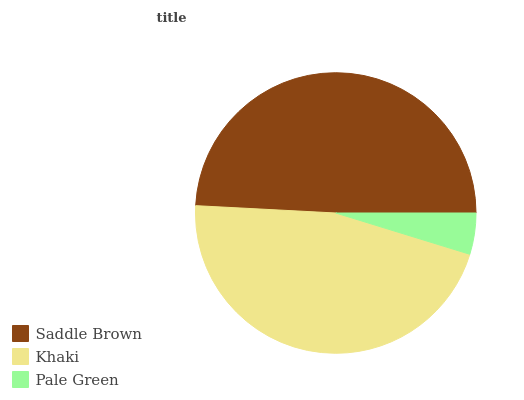Is Pale Green the minimum?
Answer yes or no. Yes. Is Saddle Brown the maximum?
Answer yes or no. Yes. Is Khaki the minimum?
Answer yes or no. No. Is Khaki the maximum?
Answer yes or no. No. Is Saddle Brown greater than Khaki?
Answer yes or no. Yes. Is Khaki less than Saddle Brown?
Answer yes or no. Yes. Is Khaki greater than Saddle Brown?
Answer yes or no. No. Is Saddle Brown less than Khaki?
Answer yes or no. No. Is Khaki the high median?
Answer yes or no. Yes. Is Khaki the low median?
Answer yes or no. Yes. Is Saddle Brown the high median?
Answer yes or no. No. Is Pale Green the low median?
Answer yes or no. No. 